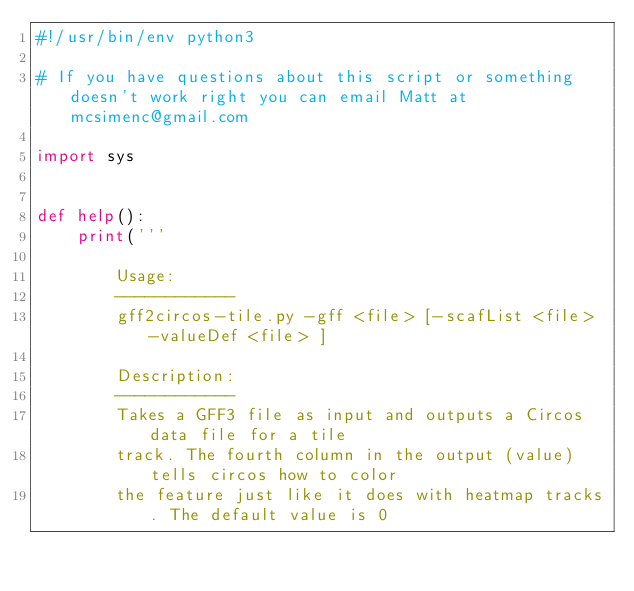<code> <loc_0><loc_0><loc_500><loc_500><_Python_>#!/usr/bin/env python3

# If you have questions about this script or something doesn't work right you can email Matt at mcsimenc@gmail.com

import sys


def help():
	print('''

		Usage:
		------------
		gff2circos-tile.py -gff <file> [-scafList <file> -valueDef <file> ]

		Description:
		------------
		Takes a GFF3 file as input and outputs a Circos data file for a tile
		track. The fourth column in the output (value) tells circos how to color
		the feature just like it does with heatmap tracks. The default value is 0</code> 